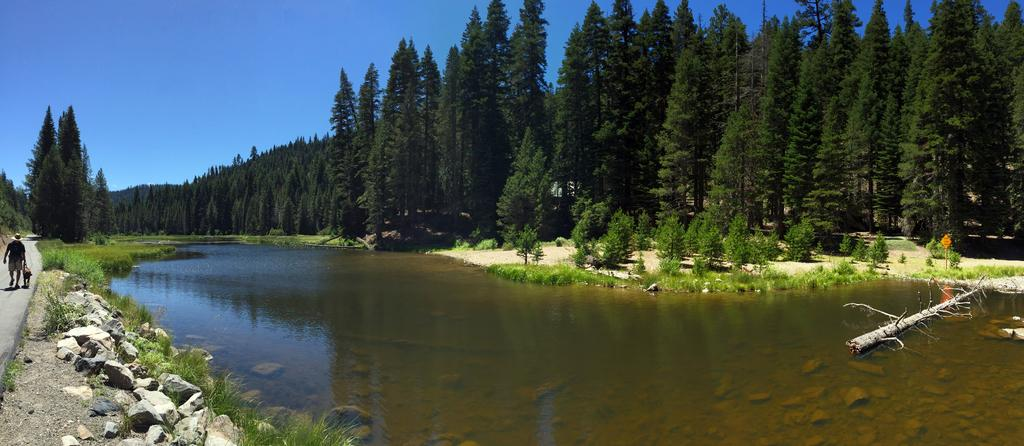What type of vegetation is present in the image? There are trees and grass in the image. What other natural elements can be seen in the image? There are rocks and water in the image. Can you describe the person in the image? There is a person walking on the road on the left side of the image. What is visible in the background of the image? The sky is visible in the background of the image. What type of chess piece is on the ground near the water in the image? There is no chess piece present in the image; it features trees, grass, rocks, water, and a person walking on the road. 